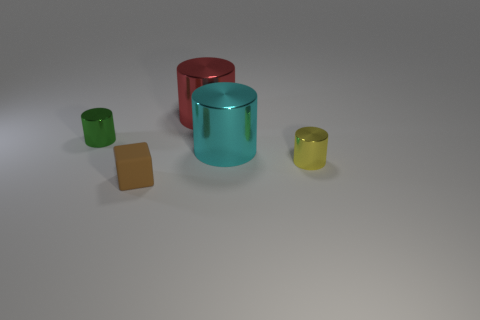Subtract all yellow metallic cylinders. How many cylinders are left? 3 Subtract all yellow cylinders. How many cylinders are left? 3 Subtract 2 cylinders. How many cylinders are left? 2 Add 5 small yellow shiny objects. How many objects exist? 10 Subtract all purple cylinders. Subtract all blue spheres. How many cylinders are left? 4 Subtract all cylinders. How many objects are left? 1 Add 1 big purple metal balls. How many big purple metal balls exist? 1 Subtract 0 gray blocks. How many objects are left? 5 Subtract all red cylinders. Subtract all cyan metallic things. How many objects are left? 3 Add 4 large cyan cylinders. How many large cyan cylinders are left? 5 